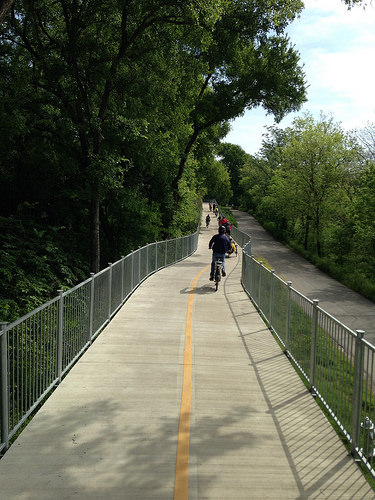<image>
Can you confirm if the biker is on the street? No. The biker is not positioned on the street. They may be near each other, but the biker is not supported by or resting on top of the street. Is the tree to the left of the fence? Yes. From this viewpoint, the tree is positioned to the left side relative to the fence. 